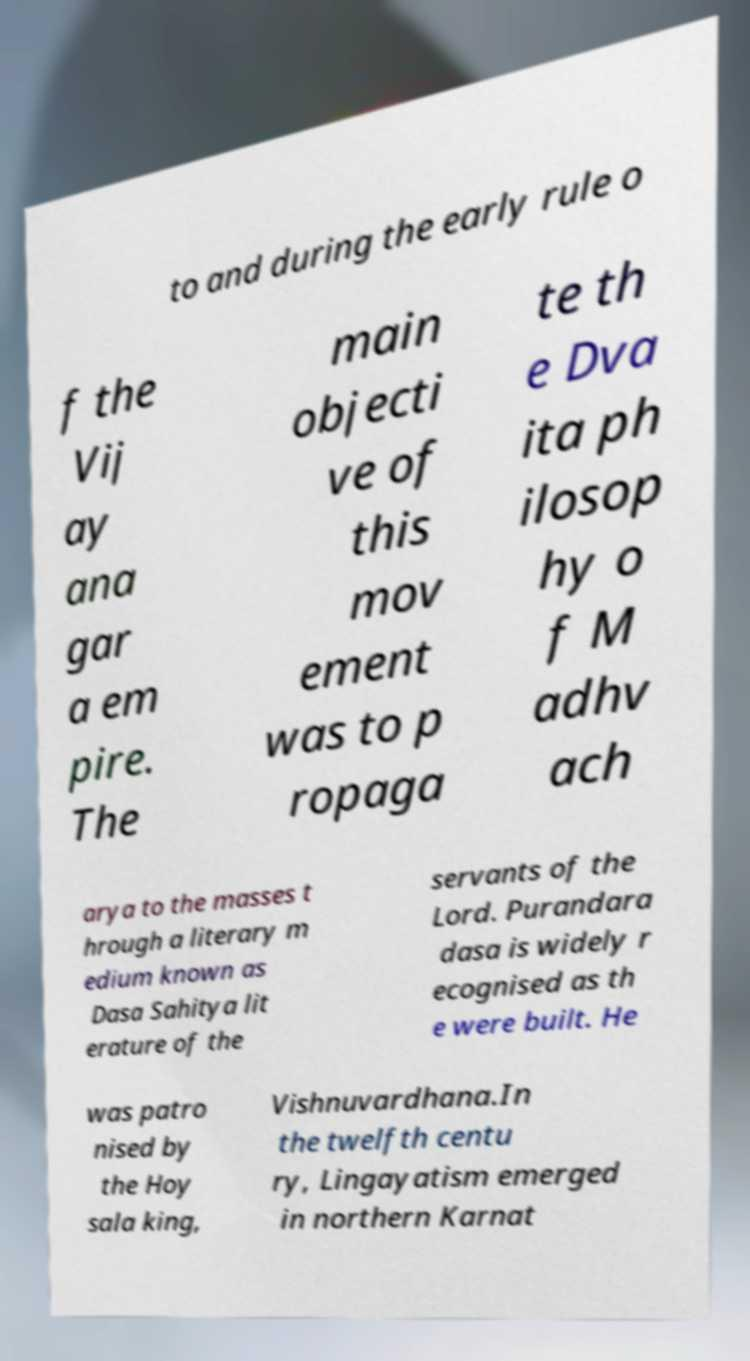Could you extract and type out the text from this image? to and during the early rule o f the Vij ay ana gar a em pire. The main objecti ve of this mov ement was to p ropaga te th e Dva ita ph ilosop hy o f M adhv ach arya to the masses t hrough a literary m edium known as Dasa Sahitya lit erature of the servants of the Lord. Purandara dasa is widely r ecognised as th e were built. He was patro nised by the Hoy sala king, Vishnuvardhana.In the twelfth centu ry, Lingayatism emerged in northern Karnat 